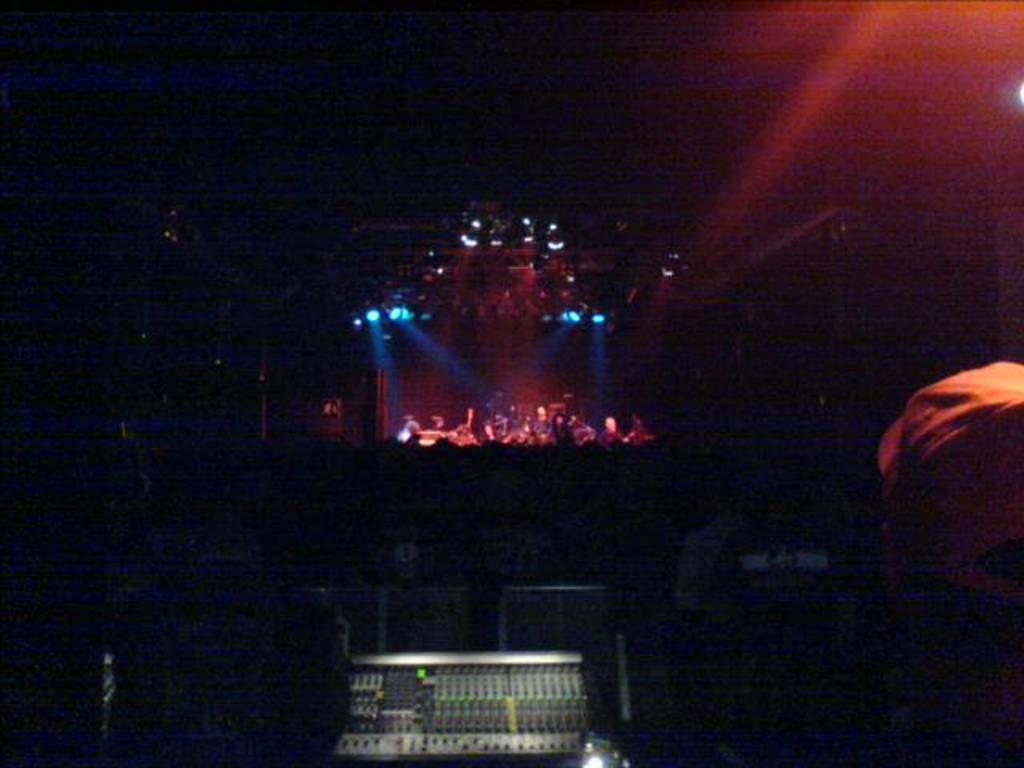Please provide a concise description of this image. In this image, we can see the stage with some objects. We can see some devices and a person on the right. We can see some lights and the dark background. 